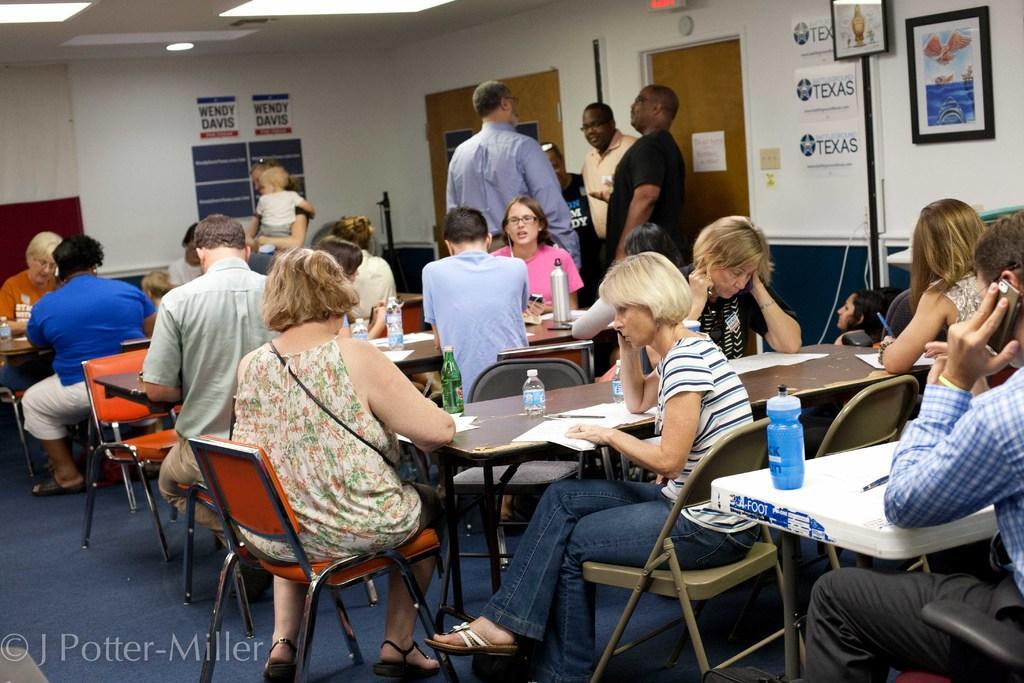How would you summarize this image in a sentence or two? In this picture, there are many people sitting in front of their respective tables. On the table there is a water bottle, some books, papers and pens. There are some men standing here. In the background there is a door and a wall here. 